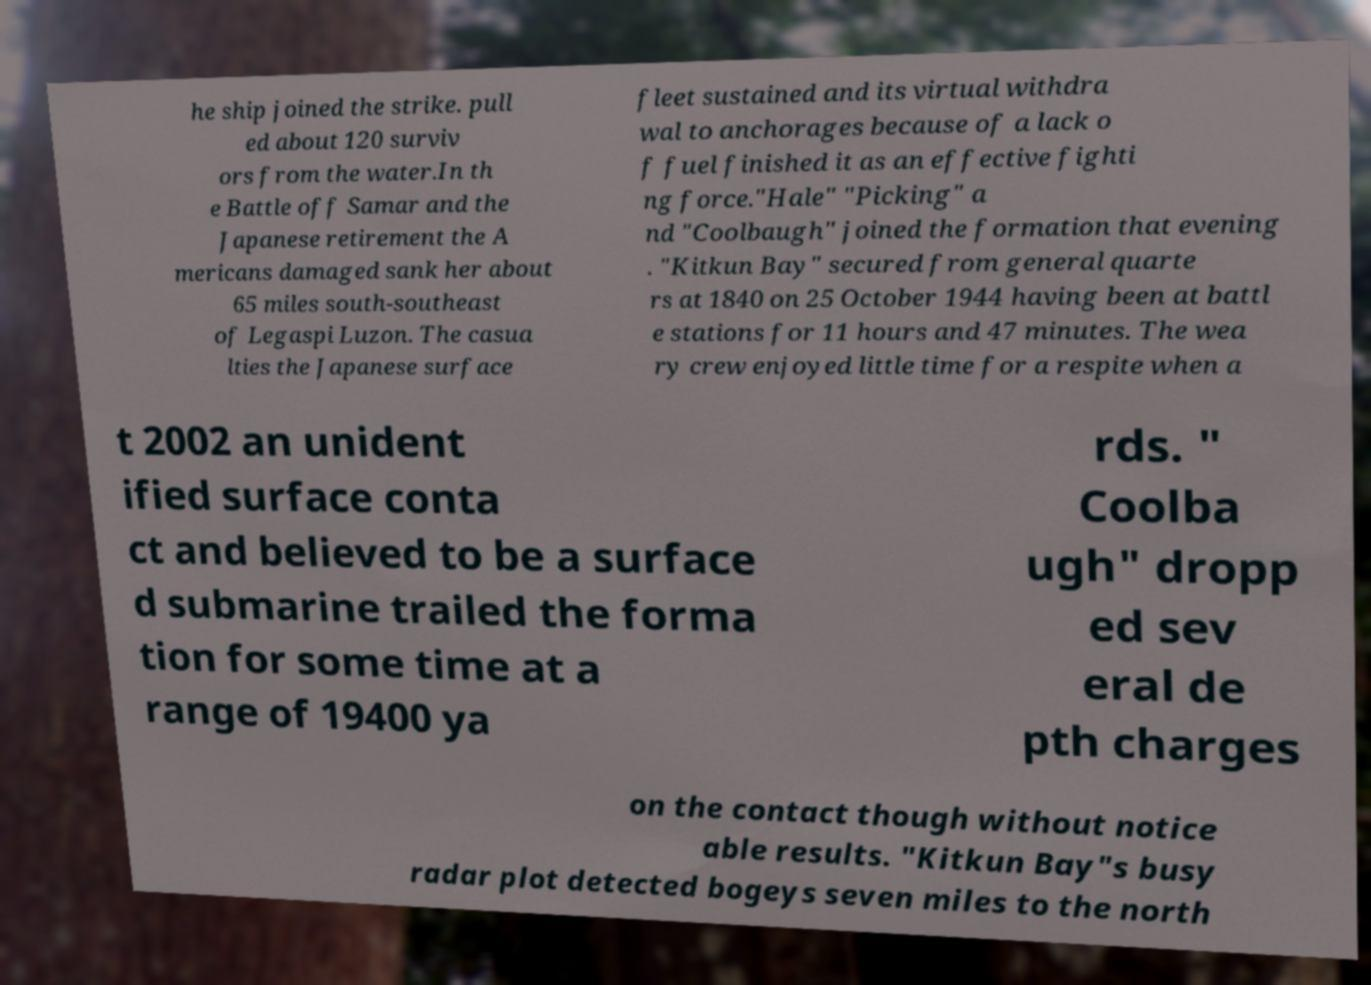Could you extract and type out the text from this image? he ship joined the strike. pull ed about 120 surviv ors from the water.In th e Battle off Samar and the Japanese retirement the A mericans damaged sank her about 65 miles south-southeast of Legaspi Luzon. The casua lties the Japanese surface fleet sustained and its virtual withdra wal to anchorages because of a lack o f fuel finished it as an effective fighti ng force."Hale" "Picking" a nd "Coolbaugh" joined the formation that evening . "Kitkun Bay" secured from general quarte rs at 1840 on 25 October 1944 having been at battl e stations for 11 hours and 47 minutes. The wea ry crew enjoyed little time for a respite when a t 2002 an unident ified surface conta ct and believed to be a surface d submarine trailed the forma tion for some time at a range of 19400 ya rds. " Coolba ugh" dropp ed sev eral de pth charges on the contact though without notice able results. "Kitkun Bay"s busy radar plot detected bogeys seven miles to the north 